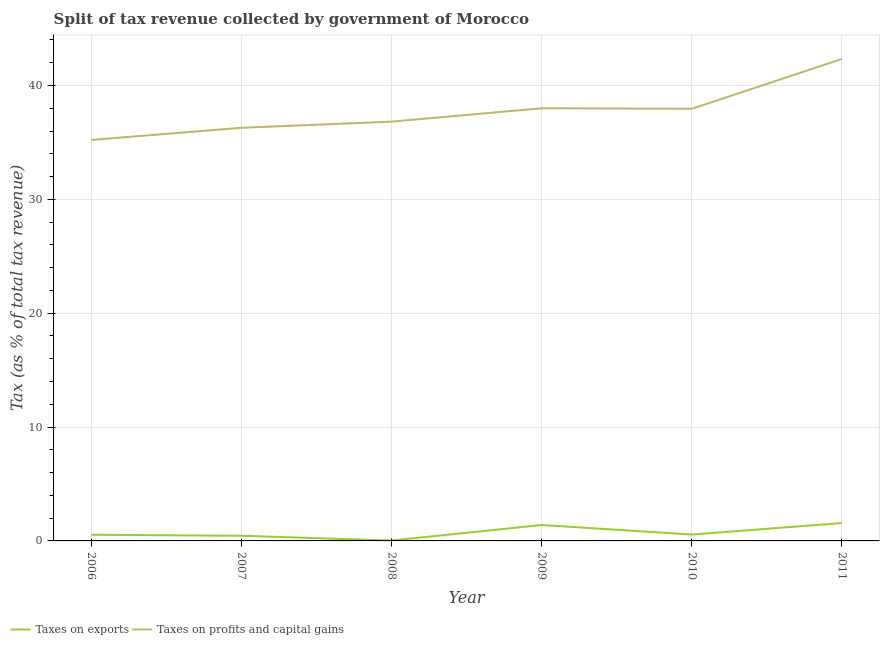How many different coloured lines are there?
Your answer should be very brief. 2. What is the percentage of revenue obtained from taxes on exports in 2007?
Provide a succinct answer. 0.45. Across all years, what is the maximum percentage of revenue obtained from taxes on profits and capital gains?
Offer a very short reply. 42.33. Across all years, what is the minimum percentage of revenue obtained from taxes on profits and capital gains?
Your answer should be compact. 35.22. In which year was the percentage of revenue obtained from taxes on exports maximum?
Make the answer very short. 2011. What is the total percentage of revenue obtained from taxes on profits and capital gains in the graph?
Your answer should be compact. 226.62. What is the difference between the percentage of revenue obtained from taxes on exports in 2008 and that in 2009?
Provide a short and direct response. -1.37. What is the difference between the percentage of revenue obtained from taxes on exports in 2006 and the percentage of revenue obtained from taxes on profits and capital gains in 2011?
Keep it short and to the point. -41.79. What is the average percentage of revenue obtained from taxes on exports per year?
Provide a succinct answer. 0.76. In the year 2011, what is the difference between the percentage of revenue obtained from taxes on exports and percentage of revenue obtained from taxes on profits and capital gains?
Offer a terse response. -40.76. What is the ratio of the percentage of revenue obtained from taxes on exports in 2007 to that in 2009?
Your response must be concise. 0.32. Is the percentage of revenue obtained from taxes on profits and capital gains in 2008 less than that in 2010?
Keep it short and to the point. Yes. Is the difference between the percentage of revenue obtained from taxes on exports in 2009 and 2011 greater than the difference between the percentage of revenue obtained from taxes on profits and capital gains in 2009 and 2011?
Your answer should be very brief. Yes. What is the difference between the highest and the second highest percentage of revenue obtained from taxes on profits and capital gains?
Ensure brevity in your answer.  4.33. What is the difference between the highest and the lowest percentage of revenue obtained from taxes on exports?
Offer a terse response. 1.54. In how many years, is the percentage of revenue obtained from taxes on profits and capital gains greater than the average percentage of revenue obtained from taxes on profits and capital gains taken over all years?
Your response must be concise. 3. Does the percentage of revenue obtained from taxes on exports monotonically increase over the years?
Provide a short and direct response. No. Is the percentage of revenue obtained from taxes on profits and capital gains strictly greater than the percentage of revenue obtained from taxes on exports over the years?
Offer a terse response. Yes. Is the percentage of revenue obtained from taxes on exports strictly less than the percentage of revenue obtained from taxes on profits and capital gains over the years?
Provide a succinct answer. Yes. How many lines are there?
Your answer should be very brief. 2. How many years are there in the graph?
Your answer should be compact. 6. Are the values on the major ticks of Y-axis written in scientific E-notation?
Your answer should be compact. No. How many legend labels are there?
Keep it short and to the point. 2. What is the title of the graph?
Ensure brevity in your answer.  Split of tax revenue collected by government of Morocco. What is the label or title of the Y-axis?
Make the answer very short. Tax (as % of total tax revenue). What is the Tax (as % of total tax revenue) in Taxes on exports in 2006?
Provide a short and direct response. 0.54. What is the Tax (as % of total tax revenue) of Taxes on profits and capital gains in 2006?
Your answer should be compact. 35.22. What is the Tax (as % of total tax revenue) of Taxes on exports in 2007?
Ensure brevity in your answer.  0.45. What is the Tax (as % of total tax revenue) in Taxes on profits and capital gains in 2007?
Offer a very short reply. 36.29. What is the Tax (as % of total tax revenue) in Taxes on exports in 2008?
Keep it short and to the point. 0.03. What is the Tax (as % of total tax revenue) of Taxes on profits and capital gains in 2008?
Your response must be concise. 36.83. What is the Tax (as % of total tax revenue) in Taxes on exports in 2009?
Provide a short and direct response. 1.4. What is the Tax (as % of total tax revenue) of Taxes on profits and capital gains in 2009?
Your answer should be very brief. 38. What is the Tax (as % of total tax revenue) in Taxes on exports in 2010?
Keep it short and to the point. 0.56. What is the Tax (as % of total tax revenue) of Taxes on profits and capital gains in 2010?
Ensure brevity in your answer.  37.96. What is the Tax (as % of total tax revenue) in Taxes on exports in 2011?
Offer a terse response. 1.57. What is the Tax (as % of total tax revenue) of Taxes on profits and capital gains in 2011?
Offer a very short reply. 42.33. Across all years, what is the maximum Tax (as % of total tax revenue) in Taxes on exports?
Keep it short and to the point. 1.57. Across all years, what is the maximum Tax (as % of total tax revenue) in Taxes on profits and capital gains?
Offer a very short reply. 42.33. Across all years, what is the minimum Tax (as % of total tax revenue) of Taxes on exports?
Provide a short and direct response. 0.03. Across all years, what is the minimum Tax (as % of total tax revenue) in Taxes on profits and capital gains?
Provide a succinct answer. 35.22. What is the total Tax (as % of total tax revenue) of Taxes on exports in the graph?
Offer a terse response. 4.55. What is the total Tax (as % of total tax revenue) of Taxes on profits and capital gains in the graph?
Your response must be concise. 226.62. What is the difference between the Tax (as % of total tax revenue) of Taxes on exports in 2006 and that in 2007?
Make the answer very short. 0.09. What is the difference between the Tax (as % of total tax revenue) of Taxes on profits and capital gains in 2006 and that in 2007?
Ensure brevity in your answer.  -1.07. What is the difference between the Tax (as % of total tax revenue) of Taxes on exports in 2006 and that in 2008?
Provide a succinct answer. 0.51. What is the difference between the Tax (as % of total tax revenue) of Taxes on profits and capital gains in 2006 and that in 2008?
Provide a succinct answer. -1.61. What is the difference between the Tax (as % of total tax revenue) of Taxes on exports in 2006 and that in 2009?
Offer a very short reply. -0.86. What is the difference between the Tax (as % of total tax revenue) of Taxes on profits and capital gains in 2006 and that in 2009?
Offer a terse response. -2.78. What is the difference between the Tax (as % of total tax revenue) of Taxes on exports in 2006 and that in 2010?
Provide a succinct answer. -0.02. What is the difference between the Tax (as % of total tax revenue) in Taxes on profits and capital gains in 2006 and that in 2010?
Your answer should be compact. -2.74. What is the difference between the Tax (as % of total tax revenue) in Taxes on exports in 2006 and that in 2011?
Your answer should be compact. -1.03. What is the difference between the Tax (as % of total tax revenue) in Taxes on profits and capital gains in 2006 and that in 2011?
Your answer should be compact. -7.11. What is the difference between the Tax (as % of total tax revenue) in Taxes on exports in 2007 and that in 2008?
Keep it short and to the point. 0.42. What is the difference between the Tax (as % of total tax revenue) in Taxes on profits and capital gains in 2007 and that in 2008?
Your response must be concise. -0.54. What is the difference between the Tax (as % of total tax revenue) of Taxes on exports in 2007 and that in 2009?
Your answer should be compact. -0.95. What is the difference between the Tax (as % of total tax revenue) of Taxes on profits and capital gains in 2007 and that in 2009?
Provide a short and direct response. -1.71. What is the difference between the Tax (as % of total tax revenue) in Taxes on exports in 2007 and that in 2010?
Keep it short and to the point. -0.11. What is the difference between the Tax (as % of total tax revenue) in Taxes on profits and capital gains in 2007 and that in 2010?
Ensure brevity in your answer.  -1.67. What is the difference between the Tax (as % of total tax revenue) of Taxes on exports in 2007 and that in 2011?
Provide a short and direct response. -1.12. What is the difference between the Tax (as % of total tax revenue) of Taxes on profits and capital gains in 2007 and that in 2011?
Make the answer very short. -6.04. What is the difference between the Tax (as % of total tax revenue) of Taxes on exports in 2008 and that in 2009?
Keep it short and to the point. -1.37. What is the difference between the Tax (as % of total tax revenue) in Taxes on profits and capital gains in 2008 and that in 2009?
Provide a short and direct response. -1.18. What is the difference between the Tax (as % of total tax revenue) in Taxes on exports in 2008 and that in 2010?
Give a very brief answer. -0.53. What is the difference between the Tax (as % of total tax revenue) of Taxes on profits and capital gains in 2008 and that in 2010?
Provide a short and direct response. -1.13. What is the difference between the Tax (as % of total tax revenue) of Taxes on exports in 2008 and that in 2011?
Your answer should be compact. -1.54. What is the difference between the Tax (as % of total tax revenue) of Taxes on profits and capital gains in 2008 and that in 2011?
Give a very brief answer. -5.51. What is the difference between the Tax (as % of total tax revenue) of Taxes on exports in 2009 and that in 2010?
Provide a succinct answer. 0.84. What is the difference between the Tax (as % of total tax revenue) of Taxes on profits and capital gains in 2009 and that in 2010?
Your answer should be very brief. 0.05. What is the difference between the Tax (as % of total tax revenue) in Taxes on exports in 2009 and that in 2011?
Provide a succinct answer. -0.17. What is the difference between the Tax (as % of total tax revenue) in Taxes on profits and capital gains in 2009 and that in 2011?
Offer a terse response. -4.33. What is the difference between the Tax (as % of total tax revenue) of Taxes on exports in 2010 and that in 2011?
Give a very brief answer. -1.01. What is the difference between the Tax (as % of total tax revenue) in Taxes on profits and capital gains in 2010 and that in 2011?
Give a very brief answer. -4.38. What is the difference between the Tax (as % of total tax revenue) of Taxes on exports in 2006 and the Tax (as % of total tax revenue) of Taxes on profits and capital gains in 2007?
Your answer should be very brief. -35.75. What is the difference between the Tax (as % of total tax revenue) in Taxes on exports in 2006 and the Tax (as % of total tax revenue) in Taxes on profits and capital gains in 2008?
Offer a terse response. -36.28. What is the difference between the Tax (as % of total tax revenue) of Taxes on exports in 2006 and the Tax (as % of total tax revenue) of Taxes on profits and capital gains in 2009?
Your answer should be compact. -37.46. What is the difference between the Tax (as % of total tax revenue) in Taxes on exports in 2006 and the Tax (as % of total tax revenue) in Taxes on profits and capital gains in 2010?
Offer a terse response. -37.41. What is the difference between the Tax (as % of total tax revenue) in Taxes on exports in 2006 and the Tax (as % of total tax revenue) in Taxes on profits and capital gains in 2011?
Ensure brevity in your answer.  -41.79. What is the difference between the Tax (as % of total tax revenue) in Taxes on exports in 2007 and the Tax (as % of total tax revenue) in Taxes on profits and capital gains in 2008?
Ensure brevity in your answer.  -36.37. What is the difference between the Tax (as % of total tax revenue) of Taxes on exports in 2007 and the Tax (as % of total tax revenue) of Taxes on profits and capital gains in 2009?
Ensure brevity in your answer.  -37.55. What is the difference between the Tax (as % of total tax revenue) of Taxes on exports in 2007 and the Tax (as % of total tax revenue) of Taxes on profits and capital gains in 2010?
Provide a succinct answer. -37.5. What is the difference between the Tax (as % of total tax revenue) in Taxes on exports in 2007 and the Tax (as % of total tax revenue) in Taxes on profits and capital gains in 2011?
Give a very brief answer. -41.88. What is the difference between the Tax (as % of total tax revenue) in Taxes on exports in 2008 and the Tax (as % of total tax revenue) in Taxes on profits and capital gains in 2009?
Your response must be concise. -37.97. What is the difference between the Tax (as % of total tax revenue) of Taxes on exports in 2008 and the Tax (as % of total tax revenue) of Taxes on profits and capital gains in 2010?
Offer a terse response. -37.92. What is the difference between the Tax (as % of total tax revenue) in Taxes on exports in 2008 and the Tax (as % of total tax revenue) in Taxes on profits and capital gains in 2011?
Your answer should be compact. -42.3. What is the difference between the Tax (as % of total tax revenue) in Taxes on exports in 2009 and the Tax (as % of total tax revenue) in Taxes on profits and capital gains in 2010?
Offer a very short reply. -36.56. What is the difference between the Tax (as % of total tax revenue) in Taxes on exports in 2009 and the Tax (as % of total tax revenue) in Taxes on profits and capital gains in 2011?
Ensure brevity in your answer.  -40.93. What is the difference between the Tax (as % of total tax revenue) in Taxes on exports in 2010 and the Tax (as % of total tax revenue) in Taxes on profits and capital gains in 2011?
Provide a short and direct response. -41.77. What is the average Tax (as % of total tax revenue) of Taxes on exports per year?
Offer a terse response. 0.76. What is the average Tax (as % of total tax revenue) of Taxes on profits and capital gains per year?
Your answer should be compact. 37.77. In the year 2006, what is the difference between the Tax (as % of total tax revenue) of Taxes on exports and Tax (as % of total tax revenue) of Taxes on profits and capital gains?
Your response must be concise. -34.68. In the year 2007, what is the difference between the Tax (as % of total tax revenue) of Taxes on exports and Tax (as % of total tax revenue) of Taxes on profits and capital gains?
Provide a short and direct response. -35.83. In the year 2008, what is the difference between the Tax (as % of total tax revenue) in Taxes on exports and Tax (as % of total tax revenue) in Taxes on profits and capital gains?
Ensure brevity in your answer.  -36.79. In the year 2009, what is the difference between the Tax (as % of total tax revenue) of Taxes on exports and Tax (as % of total tax revenue) of Taxes on profits and capital gains?
Make the answer very short. -36.6. In the year 2010, what is the difference between the Tax (as % of total tax revenue) in Taxes on exports and Tax (as % of total tax revenue) in Taxes on profits and capital gains?
Ensure brevity in your answer.  -37.4. In the year 2011, what is the difference between the Tax (as % of total tax revenue) of Taxes on exports and Tax (as % of total tax revenue) of Taxes on profits and capital gains?
Make the answer very short. -40.76. What is the ratio of the Tax (as % of total tax revenue) in Taxes on exports in 2006 to that in 2007?
Make the answer very short. 1.19. What is the ratio of the Tax (as % of total tax revenue) in Taxes on profits and capital gains in 2006 to that in 2007?
Offer a very short reply. 0.97. What is the ratio of the Tax (as % of total tax revenue) of Taxes on exports in 2006 to that in 2008?
Offer a terse response. 16.55. What is the ratio of the Tax (as % of total tax revenue) in Taxes on profits and capital gains in 2006 to that in 2008?
Your answer should be compact. 0.96. What is the ratio of the Tax (as % of total tax revenue) in Taxes on exports in 2006 to that in 2009?
Offer a terse response. 0.39. What is the ratio of the Tax (as % of total tax revenue) of Taxes on profits and capital gains in 2006 to that in 2009?
Provide a succinct answer. 0.93. What is the ratio of the Tax (as % of total tax revenue) in Taxes on exports in 2006 to that in 2010?
Make the answer very short. 0.97. What is the ratio of the Tax (as % of total tax revenue) in Taxes on profits and capital gains in 2006 to that in 2010?
Make the answer very short. 0.93. What is the ratio of the Tax (as % of total tax revenue) of Taxes on exports in 2006 to that in 2011?
Offer a terse response. 0.34. What is the ratio of the Tax (as % of total tax revenue) of Taxes on profits and capital gains in 2006 to that in 2011?
Your answer should be compact. 0.83. What is the ratio of the Tax (as % of total tax revenue) in Taxes on exports in 2007 to that in 2008?
Offer a very short reply. 13.86. What is the ratio of the Tax (as % of total tax revenue) of Taxes on profits and capital gains in 2007 to that in 2008?
Offer a terse response. 0.99. What is the ratio of the Tax (as % of total tax revenue) in Taxes on exports in 2007 to that in 2009?
Make the answer very short. 0.32. What is the ratio of the Tax (as % of total tax revenue) of Taxes on profits and capital gains in 2007 to that in 2009?
Your answer should be compact. 0.95. What is the ratio of the Tax (as % of total tax revenue) of Taxes on exports in 2007 to that in 2010?
Your response must be concise. 0.81. What is the ratio of the Tax (as % of total tax revenue) of Taxes on profits and capital gains in 2007 to that in 2010?
Your response must be concise. 0.96. What is the ratio of the Tax (as % of total tax revenue) in Taxes on exports in 2007 to that in 2011?
Offer a very short reply. 0.29. What is the ratio of the Tax (as % of total tax revenue) of Taxes on profits and capital gains in 2007 to that in 2011?
Your answer should be very brief. 0.86. What is the ratio of the Tax (as % of total tax revenue) of Taxes on exports in 2008 to that in 2009?
Your answer should be compact. 0.02. What is the ratio of the Tax (as % of total tax revenue) of Taxes on exports in 2008 to that in 2010?
Ensure brevity in your answer.  0.06. What is the ratio of the Tax (as % of total tax revenue) of Taxes on profits and capital gains in 2008 to that in 2010?
Offer a terse response. 0.97. What is the ratio of the Tax (as % of total tax revenue) of Taxes on exports in 2008 to that in 2011?
Provide a short and direct response. 0.02. What is the ratio of the Tax (as % of total tax revenue) of Taxes on profits and capital gains in 2008 to that in 2011?
Offer a terse response. 0.87. What is the ratio of the Tax (as % of total tax revenue) of Taxes on exports in 2009 to that in 2010?
Provide a short and direct response. 2.5. What is the ratio of the Tax (as % of total tax revenue) of Taxes on profits and capital gains in 2009 to that in 2010?
Offer a very short reply. 1. What is the ratio of the Tax (as % of total tax revenue) of Taxes on exports in 2009 to that in 2011?
Offer a very short reply. 0.89. What is the ratio of the Tax (as % of total tax revenue) of Taxes on profits and capital gains in 2009 to that in 2011?
Keep it short and to the point. 0.9. What is the ratio of the Tax (as % of total tax revenue) of Taxes on exports in 2010 to that in 2011?
Offer a very short reply. 0.36. What is the ratio of the Tax (as % of total tax revenue) in Taxes on profits and capital gains in 2010 to that in 2011?
Keep it short and to the point. 0.9. What is the difference between the highest and the second highest Tax (as % of total tax revenue) in Taxes on exports?
Your answer should be very brief. 0.17. What is the difference between the highest and the second highest Tax (as % of total tax revenue) of Taxes on profits and capital gains?
Your answer should be very brief. 4.33. What is the difference between the highest and the lowest Tax (as % of total tax revenue) of Taxes on exports?
Make the answer very short. 1.54. What is the difference between the highest and the lowest Tax (as % of total tax revenue) in Taxes on profits and capital gains?
Give a very brief answer. 7.11. 